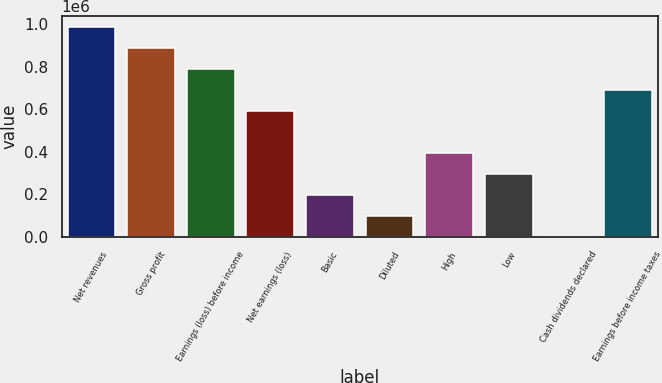Convert chart. <chart><loc_0><loc_0><loc_500><loc_500><bar_chart><fcel>Net revenues<fcel>Gross profit<fcel>Earnings (loss) before income<fcel>Net earnings (loss)<fcel>Basic<fcel>Diluted<fcel>High<fcel>Low<fcel>Cash dividends declared<fcel>Earnings before income taxes<nl><fcel>988052<fcel>889247<fcel>790442<fcel>592831<fcel>197610<fcel>98805.3<fcel>395221<fcel>296416<fcel>0.09<fcel>691636<nl></chart> 